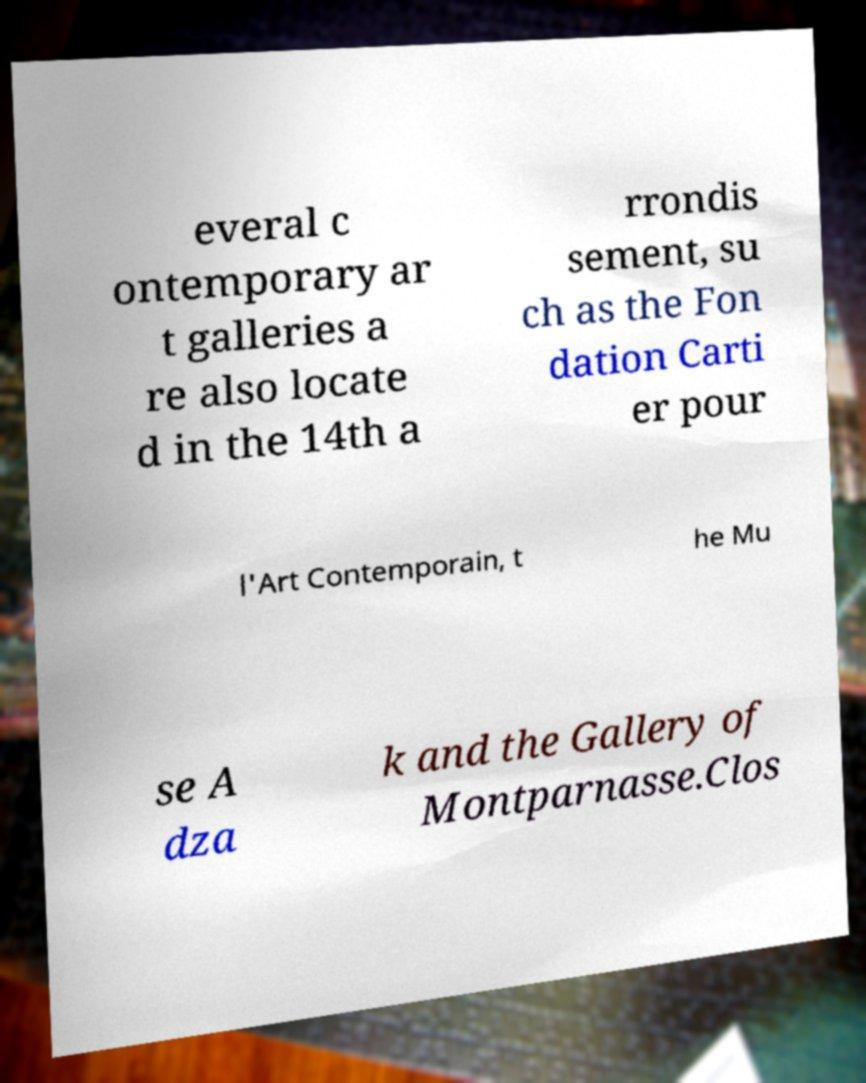I need the written content from this picture converted into text. Can you do that? everal c ontemporary ar t galleries a re also locate d in the 14th a rrondis sement, su ch as the Fon dation Carti er pour l'Art Contemporain, t he Mu se A dza k and the Gallery of Montparnasse.Clos 